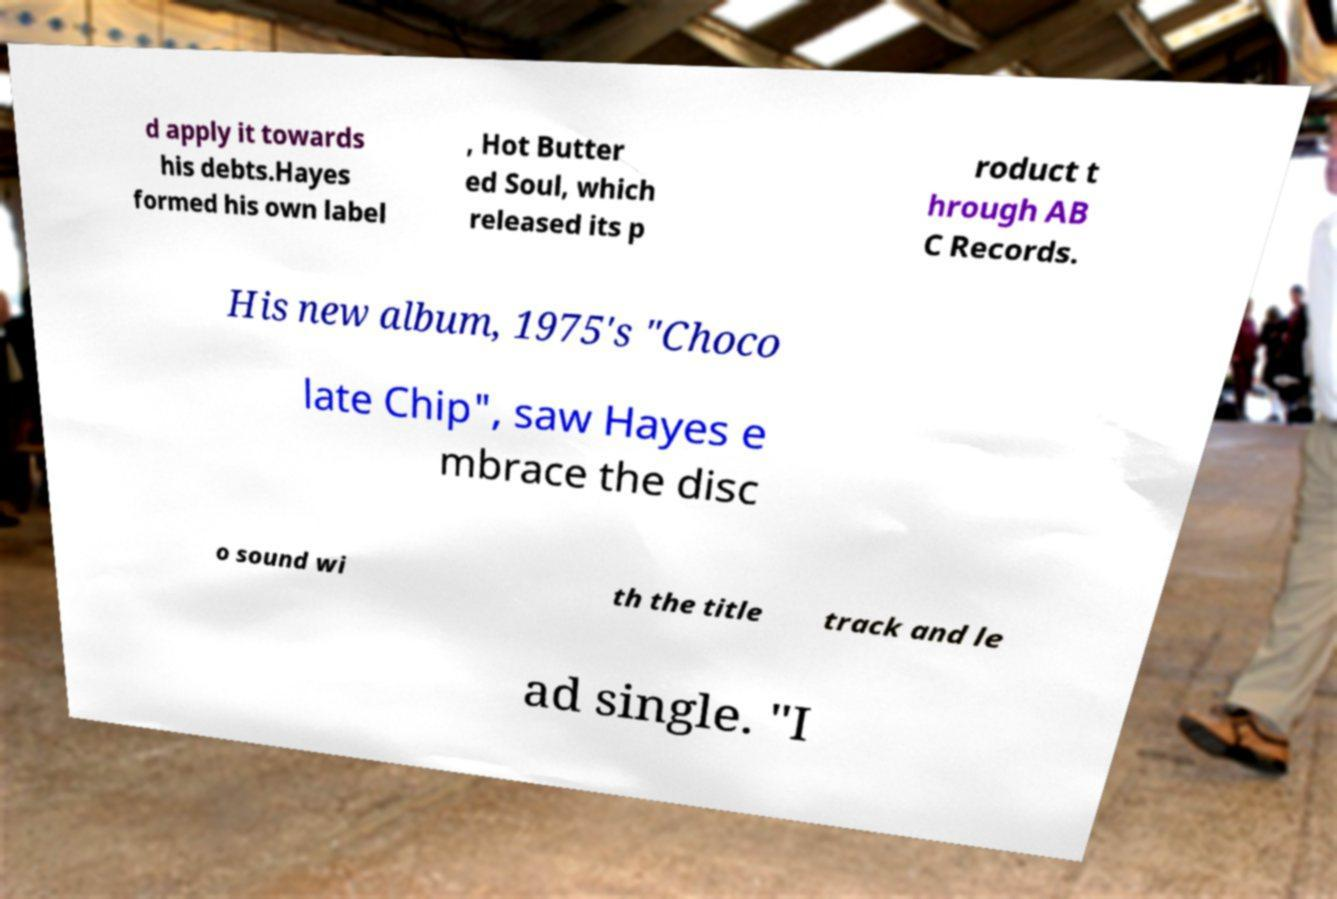Please read and relay the text visible in this image. What does it say? d apply it towards his debts.Hayes formed his own label , Hot Butter ed Soul, which released its p roduct t hrough AB C Records. His new album, 1975's "Choco late Chip", saw Hayes e mbrace the disc o sound wi th the title track and le ad single. "I 